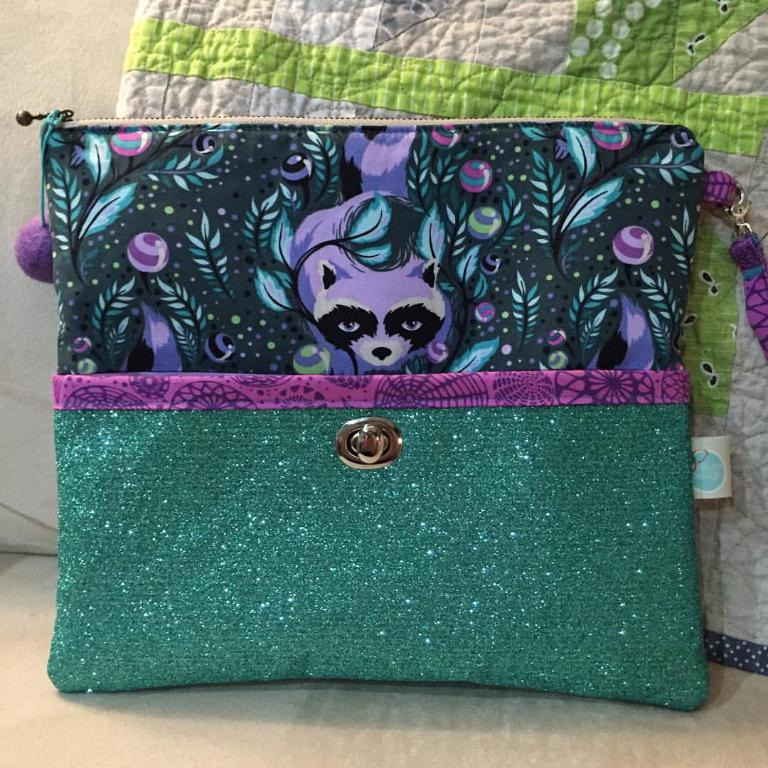What object can be seen in the image? There is a purse in the image. What is unique about the purse's appearance? The purse has green glitter and a cartoon on it. Where is the purse located in the image? The purse is placed on a sofa. What type of substance is being discussed in the image? There is no substance being discussed in the image; it features a purse with green glitter and a cartoon on it. What is the top of the purse made of? The facts provided do not mention the material of the purse's top, only that it has green glitter and a cartoon on it. 